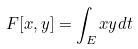<formula> <loc_0><loc_0><loc_500><loc_500>F [ x , y ] = \int _ { E } x y d t</formula> 